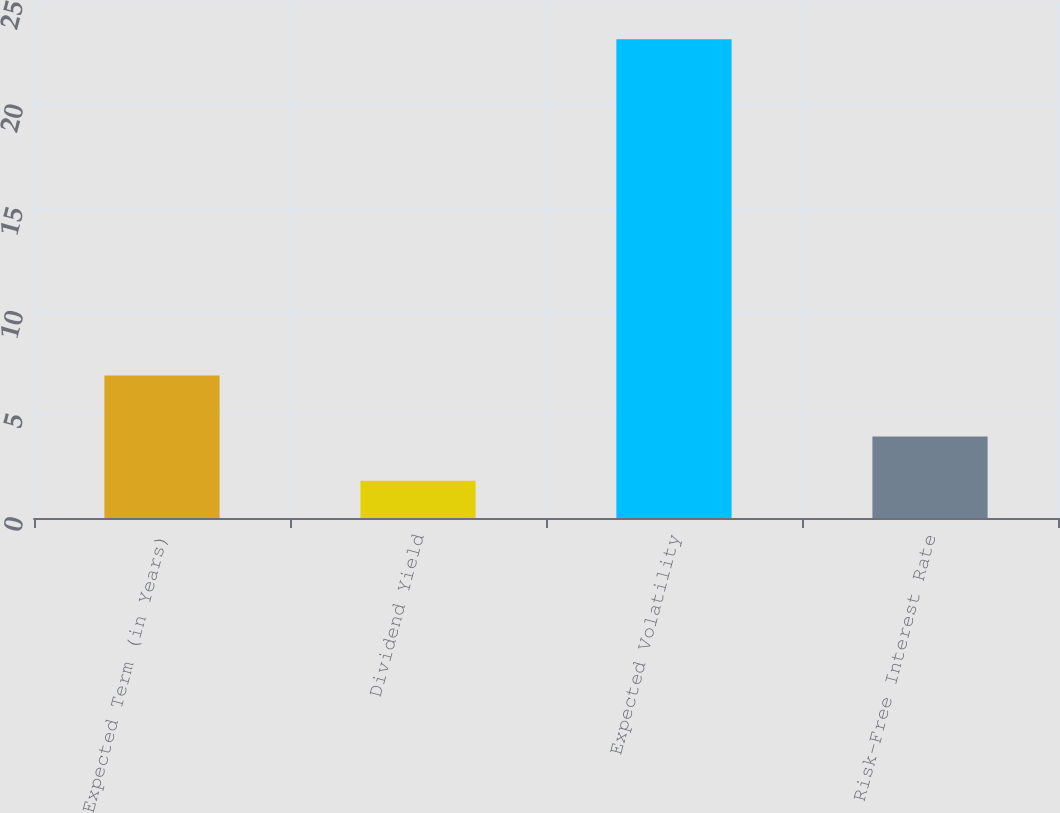Convert chart to OTSL. <chart><loc_0><loc_0><loc_500><loc_500><bar_chart><fcel>Expected Term (in Years)<fcel>Dividend Yield<fcel>Expected Volatility<fcel>Risk-Free Interest Rate<nl><fcel>6.9<fcel>1.81<fcel>23.2<fcel>3.95<nl></chart> 